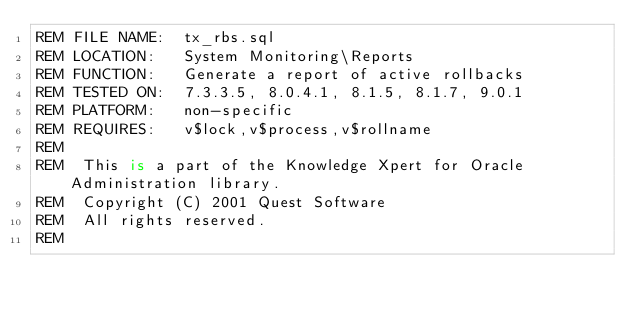<code> <loc_0><loc_0><loc_500><loc_500><_SQL_>REM FILE NAME:  tx_rbs.sql
REM LOCATION:   System Monitoring\Reports
REM FUNCTION:   Generate a report of active rollbacks
REM TESTED ON:  7.3.3.5, 8.0.4.1, 8.1.5, 8.1.7, 9.0.1
REM PLATFORM:   non-specific
REM REQUIRES:   v$lock,v$process,v$rollname
REM
REM  This is a part of the Knowledge Xpert for Oracle Administration library. 
REM  Copyright (C) 2001 Quest Software 
REM  All rights reserved. 
REM </code> 